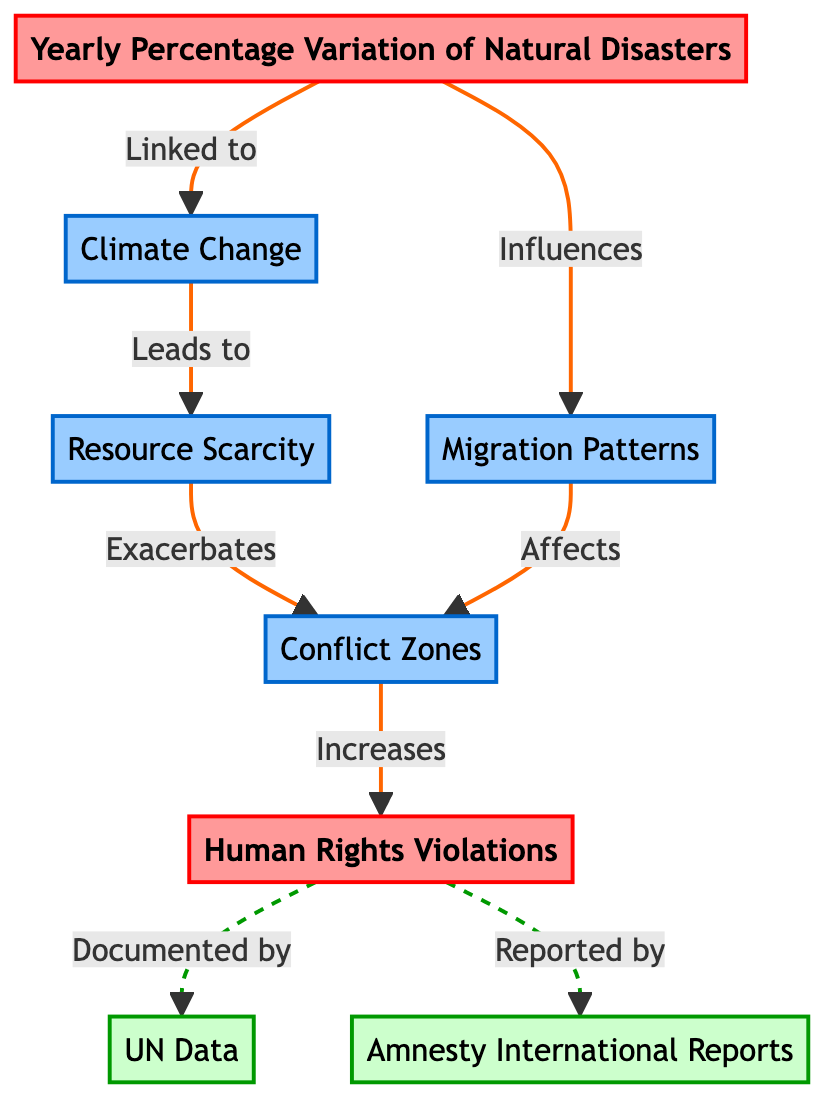What does the central node represent? The central node, labeled "Yearly Percentage Variation of Natural Disasters," signifies the primary focus of the diagram, which deals with changes in the frequency and severity of natural disasters over the years.
Answer: Yearly Percentage Variation of Natural Disasters How many secondary nodes are in the diagram? The diagram contains four secondary nodes: Climate Change, Resource Scarcity, Conflict Zones, and Migration Patterns. The count is based on the nodes classified as secondary in the diagram.
Answer: 4 What relationship exists between Resource Scarcity and Conflict Zones? Resource Scarcity leads to Conflict Zones; this relationship indicates that as resources become scarce, areas may experience increased conflict.
Answer: Leads to Which organization is associated with documenting Human Rights Violations? The UN (United Nations) is the organization documented in the diagram as responsible for recording Human Rights Violations.
Answer: UN How do Migration Patterns relate to Conflict Zones? Migration Patterns affect Conflict Zones; this means that migration, possibly due to natural disasters or other factors, has an impact on areas of conflict.
Answer: Affects What is the sequence from Climate Change to Human Rights Violations? The sequence includes Climate Change leading to Resource Scarcity, which then exacerbates Conflict Zones, ultimately resulting in Human Rights Violations. This flow illustrates a chain of causation from environmental issues to human rights issues.
Answer: Climate Change → Resource Scarcity → Conflict Zones → Human Rights Violations Which node is primarily documented by Amnesty International? Amnesty International is specifically mentioned in relation to documenting Human Rights Violations, indicating their focus on global human rights issues.
Answer: Human Rights Violations What type of flow exists between the node for Natural Disasters and the node for Migration Patterns? The flow from Natural Disasters to Migration Patterns is described as an influence; this shows how variations in natural disasters can affect human movement and migration trends.
Answer: Influences How many total nodes are shown in the diagram? The diagram contains a total of eight nodes: one main node (Yearly Percentage Variation of Natural Disasters), four secondary nodes (Climate Change, Resource Scarcity, Conflict Zones, Migration Patterns), and two data nodes (UN Data, Amnesty International Reports).
Answer: 8 